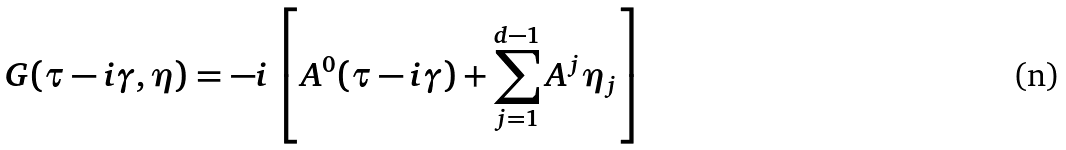Convert formula to latex. <formula><loc_0><loc_0><loc_500><loc_500>G ( \tau - i \gamma , \eta ) = - i \left [ A ^ { 0 } ( \tau - i \gamma ) + \sum _ { j = 1 } ^ { d - 1 } A ^ { j } \eta _ { j } \right ]</formula> 